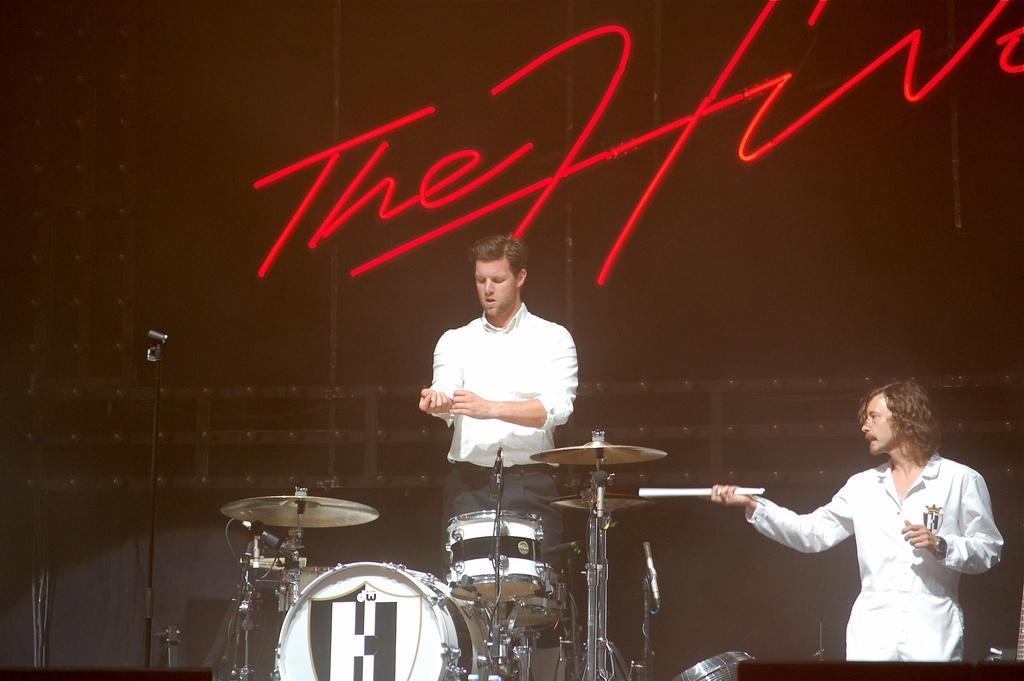Could you give a brief overview of what you see in this image? In this image we can see two persons. There are mikes and musical instruments. There is a black background and we can see something is written on it. 